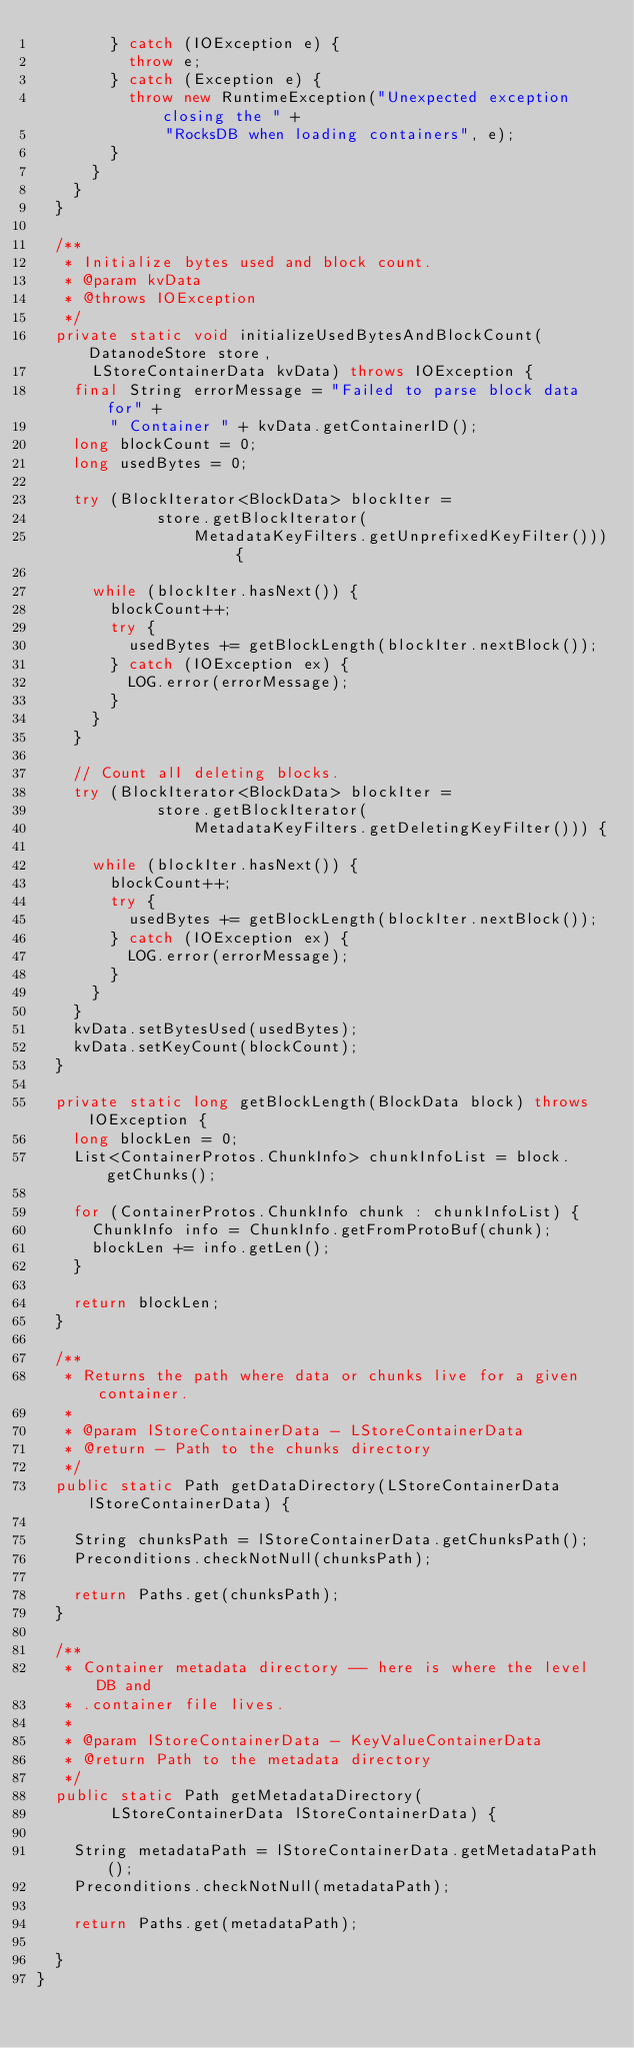<code> <loc_0><loc_0><loc_500><loc_500><_Java_>        } catch (IOException e) {
          throw e;
        } catch (Exception e) {
          throw new RuntimeException("Unexpected exception closing the " +
              "RocksDB when loading containers", e);
        }
      }
    }
  }

  /**
   * Initialize bytes used and block count.
   * @param kvData
   * @throws IOException
   */
  private static void initializeUsedBytesAndBlockCount(DatanodeStore store,
      LStoreContainerData kvData) throws IOException {
    final String errorMessage = "Failed to parse block data for" +
        " Container " + kvData.getContainerID();
    long blockCount = 0;
    long usedBytes = 0;

    try (BlockIterator<BlockData> blockIter =
             store.getBlockIterator(
                 MetadataKeyFilters.getUnprefixedKeyFilter())) {

      while (blockIter.hasNext()) {
        blockCount++;
        try {
          usedBytes += getBlockLength(blockIter.nextBlock());
        } catch (IOException ex) {
          LOG.error(errorMessage);
        }
      }
    }

    // Count all deleting blocks.
    try (BlockIterator<BlockData> blockIter =
             store.getBlockIterator(
                 MetadataKeyFilters.getDeletingKeyFilter())) {

      while (blockIter.hasNext()) {
        blockCount++;
        try {
          usedBytes += getBlockLength(blockIter.nextBlock());
        } catch (IOException ex) {
          LOG.error(errorMessage);
        }
      }
    }
    kvData.setBytesUsed(usedBytes);
    kvData.setKeyCount(blockCount);
  }

  private static long getBlockLength(BlockData block) throws IOException {
    long blockLen = 0;
    List<ContainerProtos.ChunkInfo> chunkInfoList = block.getChunks();

    for (ContainerProtos.ChunkInfo chunk : chunkInfoList) {
      ChunkInfo info = ChunkInfo.getFromProtoBuf(chunk);
      blockLen += info.getLen();
    }

    return blockLen;
  }

  /**
   * Returns the path where data or chunks live for a given container.
   *
   * @param lStoreContainerData - LStoreContainerData
   * @return - Path to the chunks directory
   */
  public static Path getDataDirectory(LStoreContainerData lStoreContainerData) {

    String chunksPath = lStoreContainerData.getChunksPath();
    Preconditions.checkNotNull(chunksPath);

    return Paths.get(chunksPath);
  }

  /**
   * Container metadata directory -- here is where the level DB and
   * .container file lives.
   *
   * @param lStoreContainerData - KeyValueContainerData
   * @return Path to the metadata directory
   */
  public static Path getMetadataDirectory(
        LStoreContainerData lStoreContainerData) {

    String metadataPath = lStoreContainerData.getMetadataPath();
    Preconditions.checkNotNull(metadataPath);

    return Paths.get(metadataPath);

  }
}
</code> 